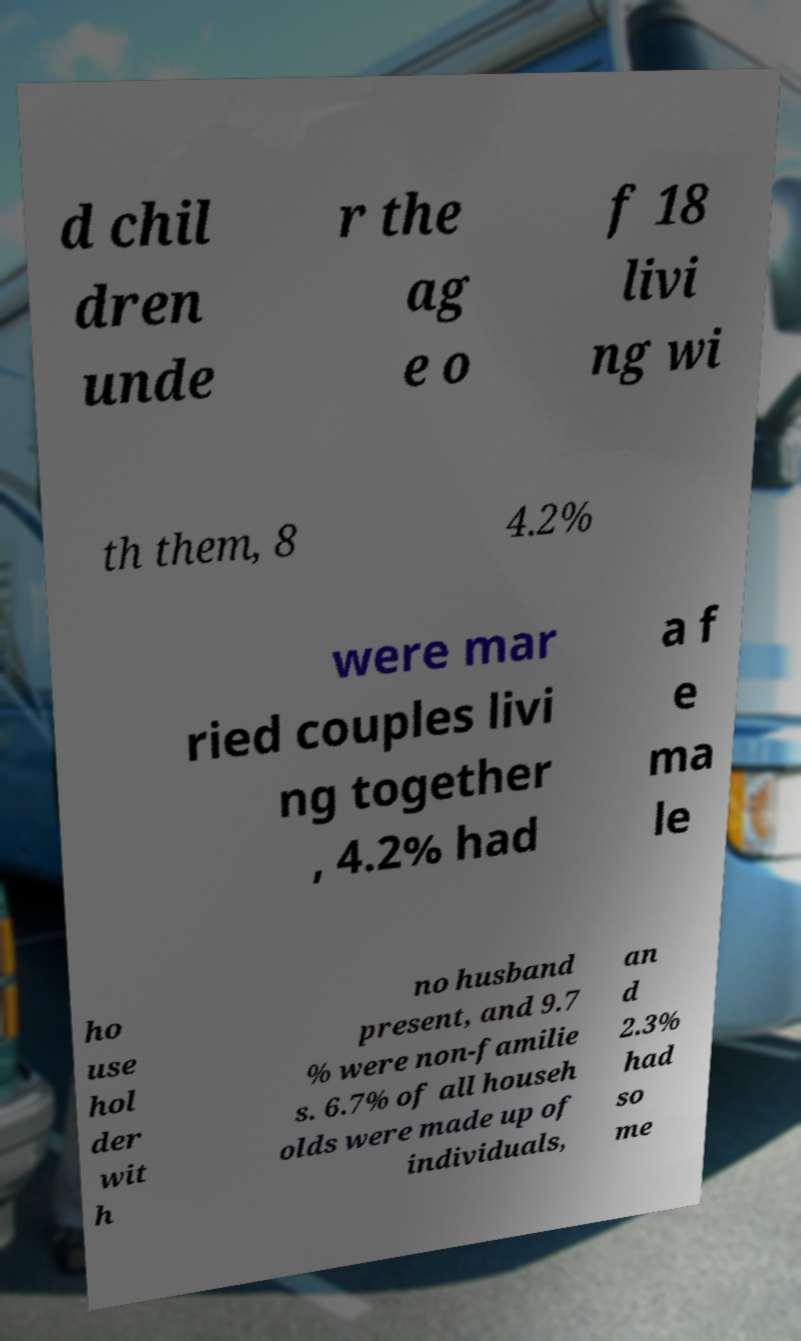For documentation purposes, I need the text within this image transcribed. Could you provide that? d chil dren unde r the ag e o f 18 livi ng wi th them, 8 4.2% were mar ried couples livi ng together , 4.2% had a f e ma le ho use hol der wit h no husband present, and 9.7 % were non-familie s. 6.7% of all househ olds were made up of individuals, an d 2.3% had so me 